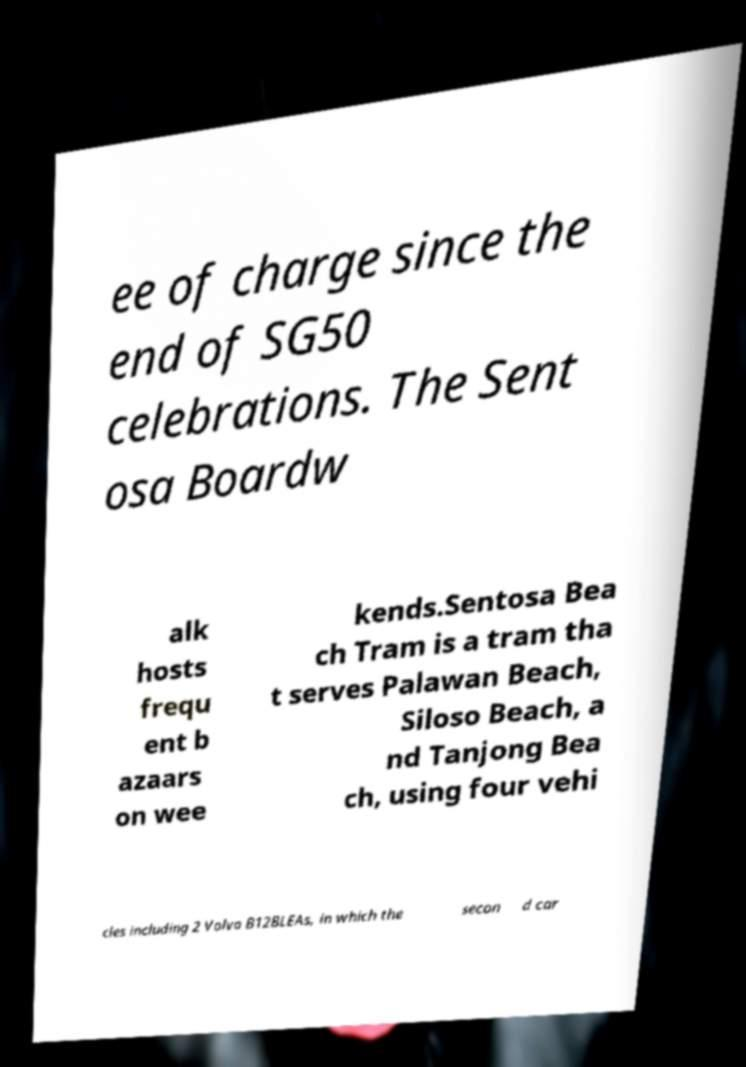There's text embedded in this image that I need extracted. Can you transcribe it verbatim? ee of charge since the end of SG50 celebrations. The Sent osa Boardw alk hosts frequ ent b azaars on wee kends.Sentosa Bea ch Tram is a tram tha t serves Palawan Beach, Siloso Beach, a nd Tanjong Bea ch, using four vehi cles including 2 Volvo B12BLEAs, in which the secon d car 